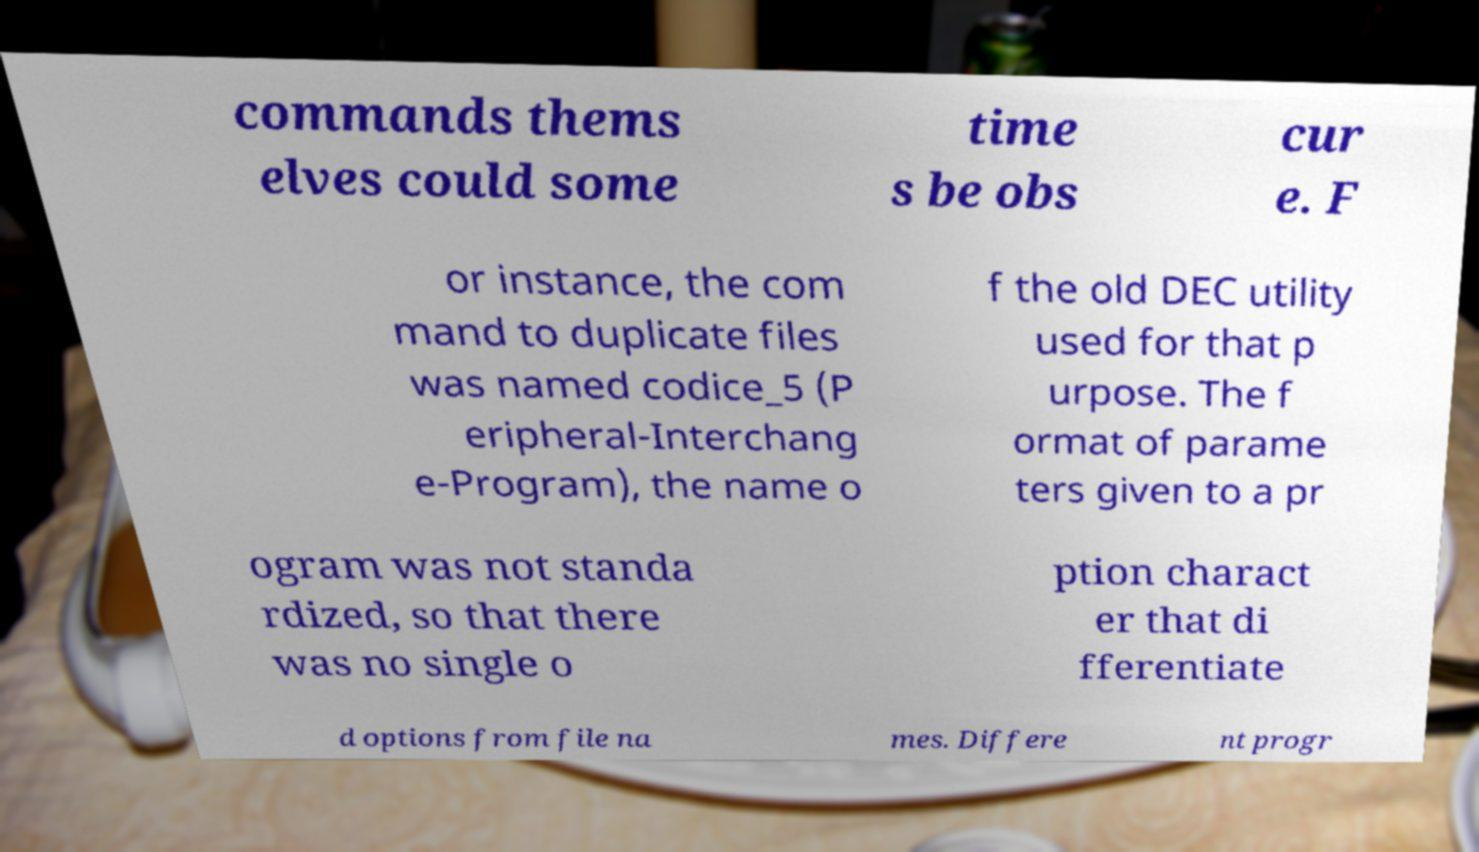Could you extract and type out the text from this image? commands thems elves could some time s be obs cur e. F or instance, the com mand to duplicate files was named codice_5 (P eripheral-Interchang e-Program), the name o f the old DEC utility used for that p urpose. The f ormat of parame ters given to a pr ogram was not standa rdized, so that there was no single o ption charact er that di fferentiate d options from file na mes. Differe nt progr 